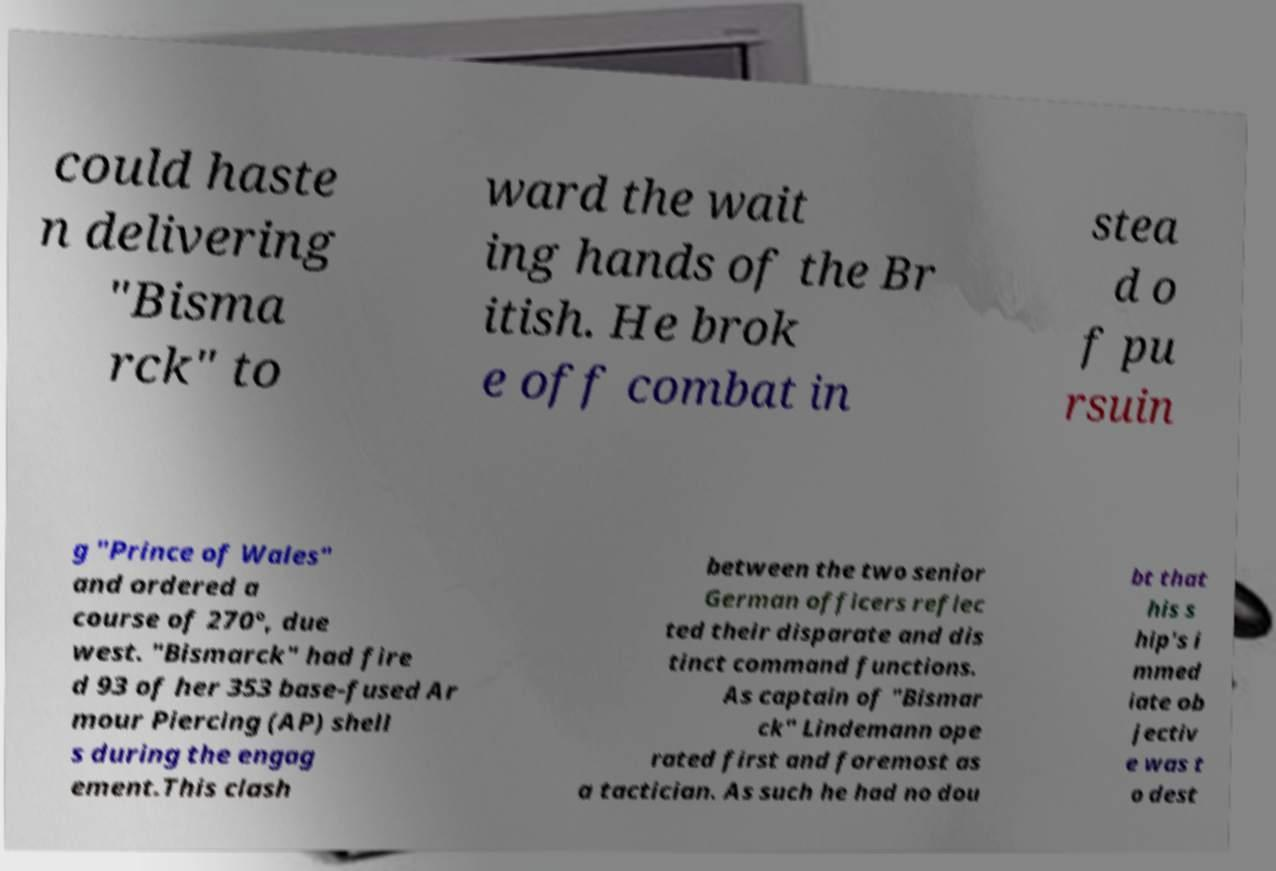Could you assist in decoding the text presented in this image and type it out clearly? could haste n delivering "Bisma rck" to ward the wait ing hands of the Br itish. He brok e off combat in stea d o f pu rsuin g "Prince of Wales" and ordered a course of 270°, due west. "Bismarck" had fire d 93 of her 353 base-fused Ar mour Piercing (AP) shell s during the engag ement.This clash between the two senior German officers reflec ted their disparate and dis tinct command functions. As captain of "Bismar ck" Lindemann ope rated first and foremost as a tactician. As such he had no dou bt that his s hip's i mmed iate ob jectiv e was t o dest 